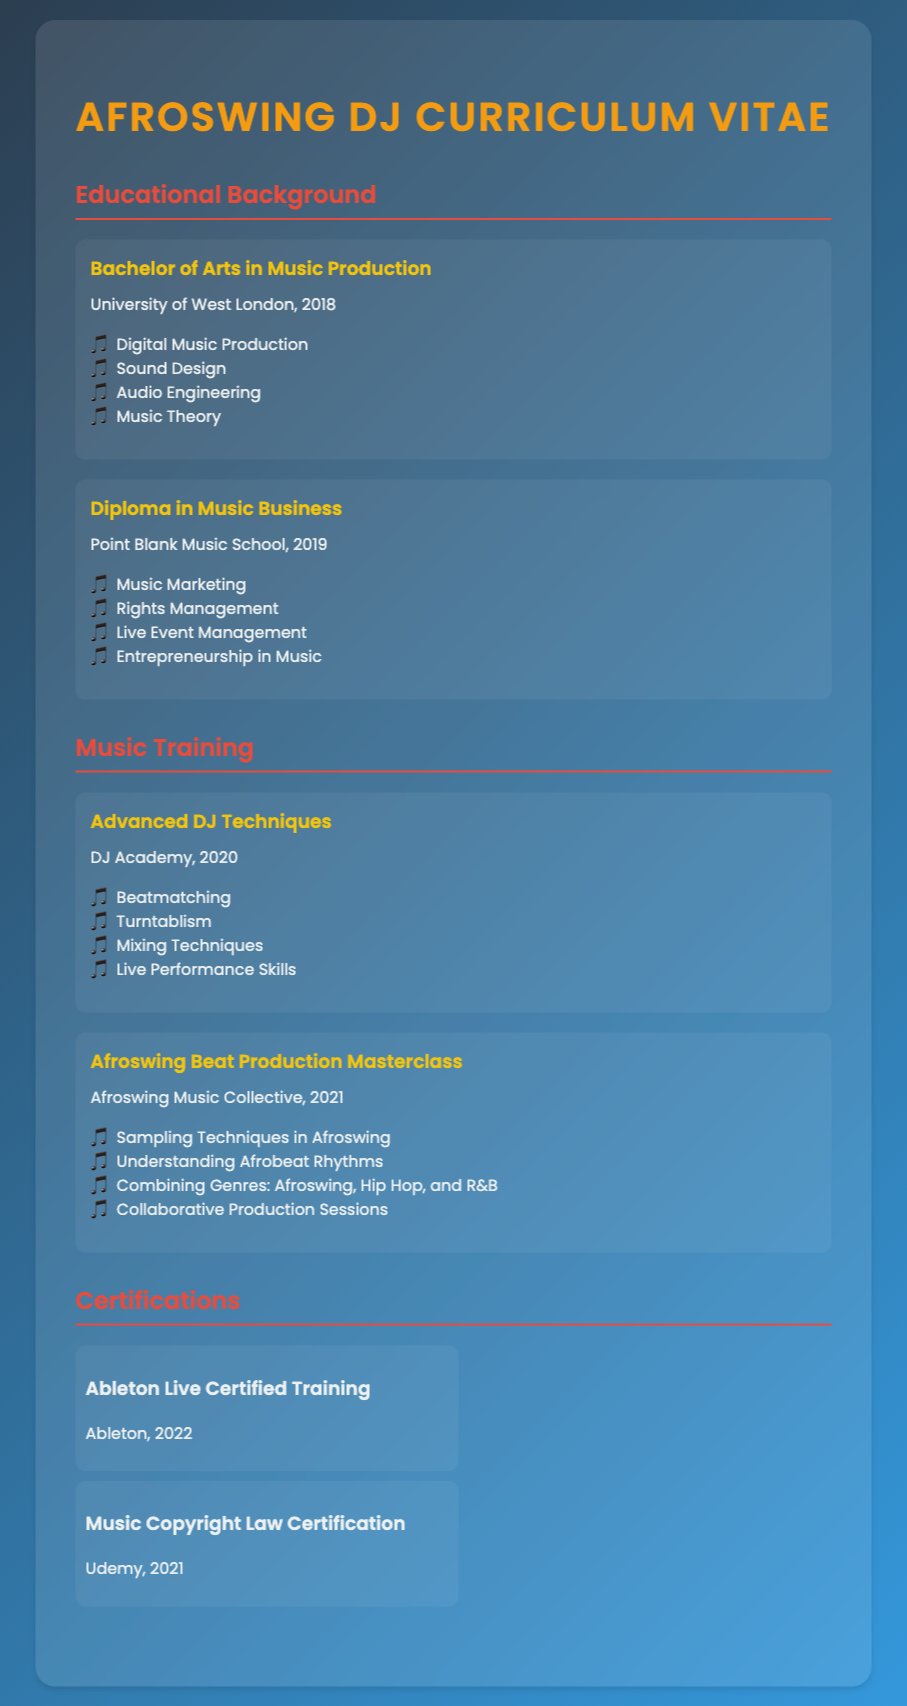what degree did you earn? The document states that the individual earned a Bachelor of Arts in Music Production.
Answer: Bachelor of Arts in Music Production which institution awarded the diploma in music business? The document mentions that the diploma in music business was awarded by Point Blank Music School.
Answer: Point Blank Music School when did you complete the Advanced DJ Techniques training? The document indicates that the Advanced DJ Techniques training was completed in 2020.
Answer: 2020 what is one topic covered in the Afroswing Beat Production Masterclass? The document lists Sampling Techniques in Afroswing as one of the topics covered.
Answer: Sampling Techniques in Afroswing how many certifications are listed in the document? The document details two certifications, Ableton Live Certified Training and Music Copyright Law Certification.
Answer: 2 which certification was acquired in 2022? The document states that the Ableton Live Certified Training was acquired in 2022.
Answer: Ableton Live Certified Training what area of music is the focus of the Afroswing Beat Production Masterclass? The document highlights that the masterclass focuses on Afroswing music.
Answer: Afroswing who organized the Afroswing Beat Production Masterclass? According to the document, the masterclass was organized by the Afroswing Music Collective.
Answer: Afroswing Music Collective 